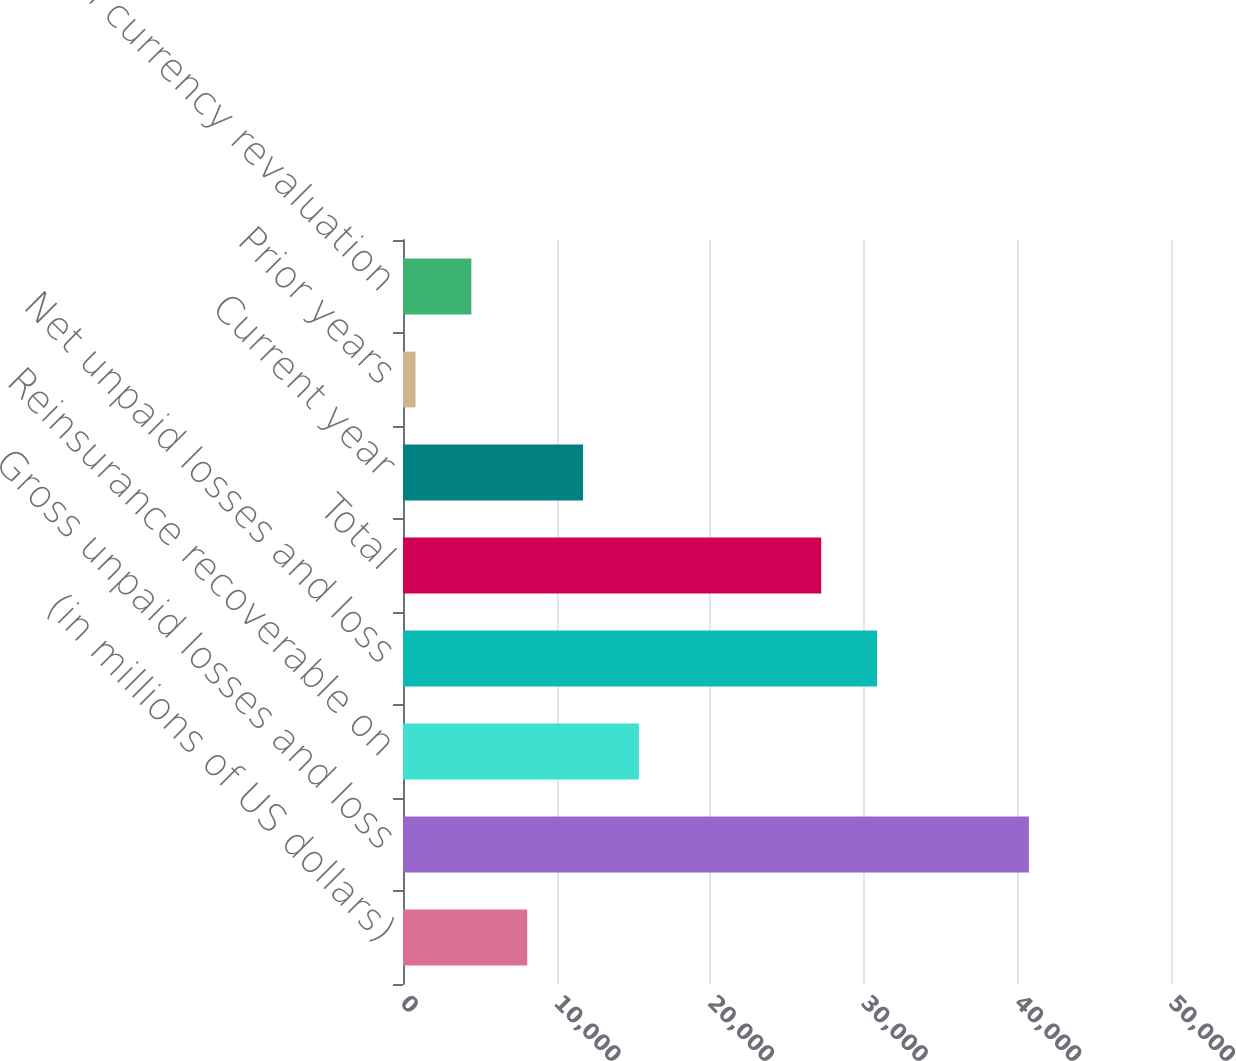Convert chart to OTSL. <chart><loc_0><loc_0><loc_500><loc_500><bar_chart><fcel>(in millions of US dollars)<fcel>Gross unpaid losses and loss<fcel>Reinsurance recoverable on<fcel>Net unpaid losses and loss<fcel>Total<fcel>Current year<fcel>Prior years<fcel>Foreign currency revaluation<nl><fcel>8086.4<fcel>40748.2<fcel>15358.8<fcel>30864.4<fcel>27228.2<fcel>11722.6<fcel>814<fcel>4450.2<nl></chart> 